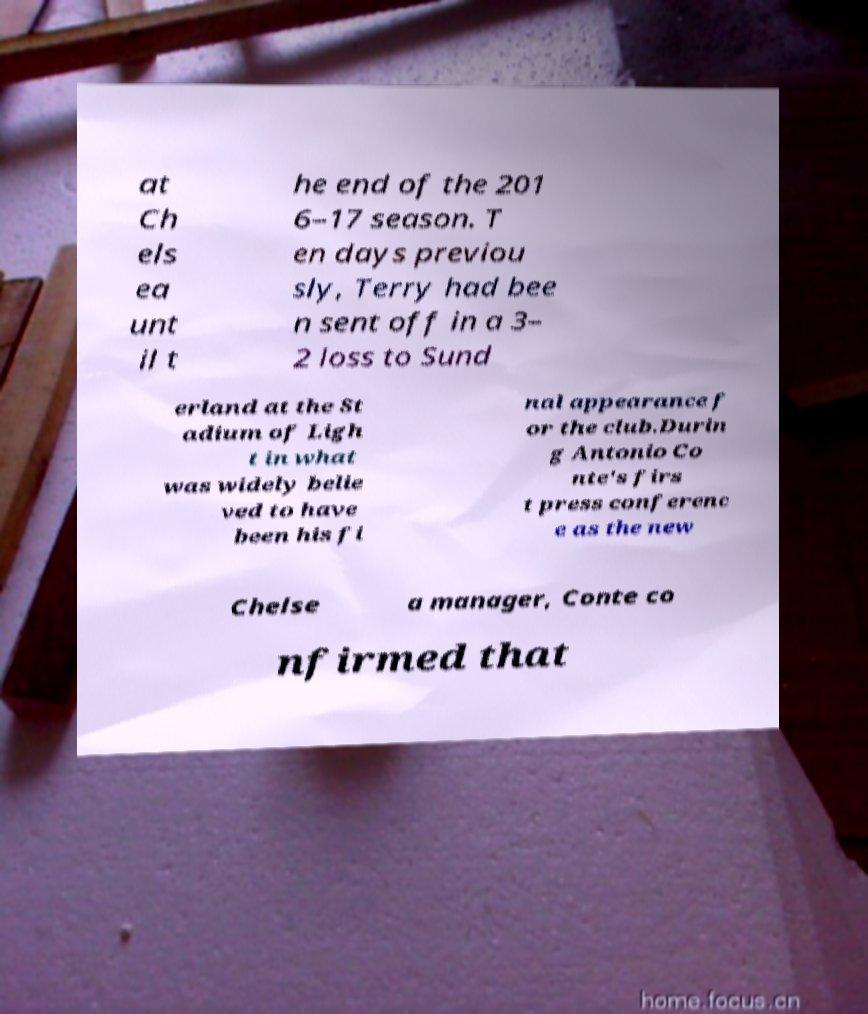Please identify and transcribe the text found in this image. at Ch els ea unt il t he end of the 201 6–17 season. T en days previou sly, Terry had bee n sent off in a 3– 2 loss to Sund erland at the St adium of Ligh t in what was widely belie ved to have been his fi nal appearance f or the club.Durin g Antonio Co nte's firs t press conferenc e as the new Chelse a manager, Conte co nfirmed that 